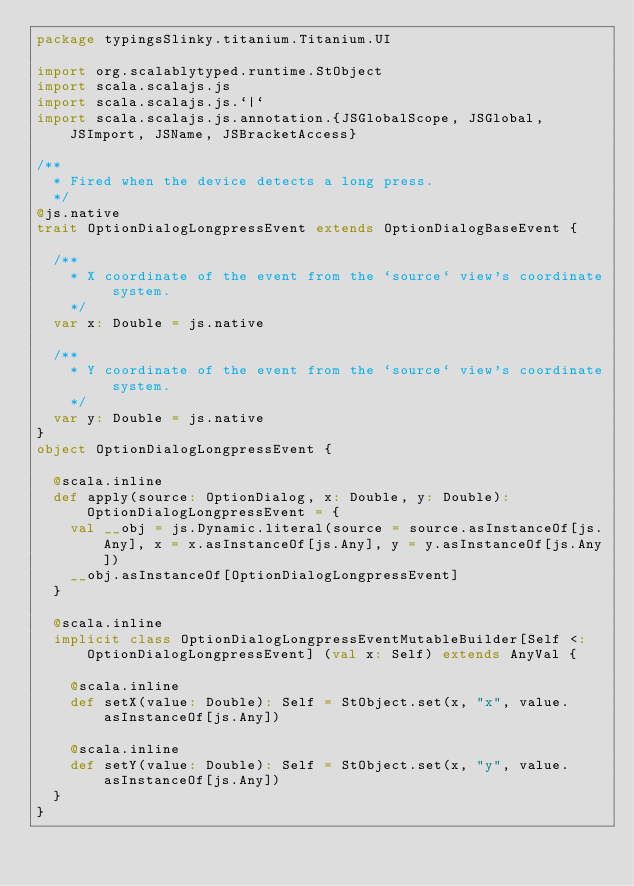Convert code to text. <code><loc_0><loc_0><loc_500><loc_500><_Scala_>package typingsSlinky.titanium.Titanium.UI

import org.scalablytyped.runtime.StObject
import scala.scalajs.js
import scala.scalajs.js.`|`
import scala.scalajs.js.annotation.{JSGlobalScope, JSGlobal, JSImport, JSName, JSBracketAccess}

/**
  * Fired when the device detects a long press.
  */
@js.native
trait OptionDialogLongpressEvent extends OptionDialogBaseEvent {
  
  /**
    * X coordinate of the event from the `source` view's coordinate system.
    */
  var x: Double = js.native
  
  /**
    * Y coordinate of the event from the `source` view's coordinate system.
    */
  var y: Double = js.native
}
object OptionDialogLongpressEvent {
  
  @scala.inline
  def apply(source: OptionDialog, x: Double, y: Double): OptionDialogLongpressEvent = {
    val __obj = js.Dynamic.literal(source = source.asInstanceOf[js.Any], x = x.asInstanceOf[js.Any], y = y.asInstanceOf[js.Any])
    __obj.asInstanceOf[OptionDialogLongpressEvent]
  }
  
  @scala.inline
  implicit class OptionDialogLongpressEventMutableBuilder[Self <: OptionDialogLongpressEvent] (val x: Self) extends AnyVal {
    
    @scala.inline
    def setX(value: Double): Self = StObject.set(x, "x", value.asInstanceOf[js.Any])
    
    @scala.inline
    def setY(value: Double): Self = StObject.set(x, "y", value.asInstanceOf[js.Any])
  }
}
</code> 